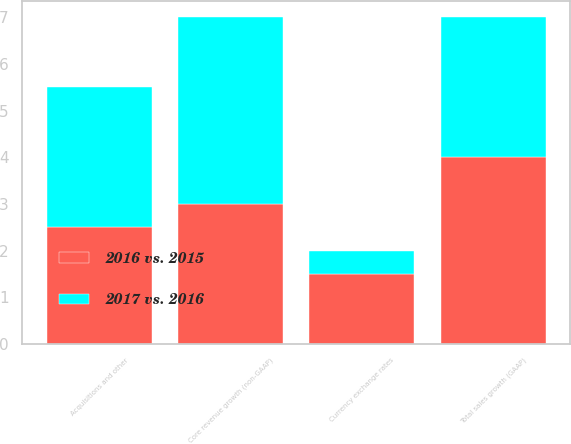<chart> <loc_0><loc_0><loc_500><loc_500><stacked_bar_chart><ecel><fcel>Total sales growth (GAAP)<fcel>Acquisitions and other<fcel>Currency exchange rates<fcel>Core revenue growth (non-GAAP)<nl><fcel>2017 vs. 2016<fcel>3<fcel>3<fcel>0.5<fcel>4<nl><fcel>2016 vs. 2015<fcel>4<fcel>2.5<fcel>1.5<fcel>3<nl></chart> 